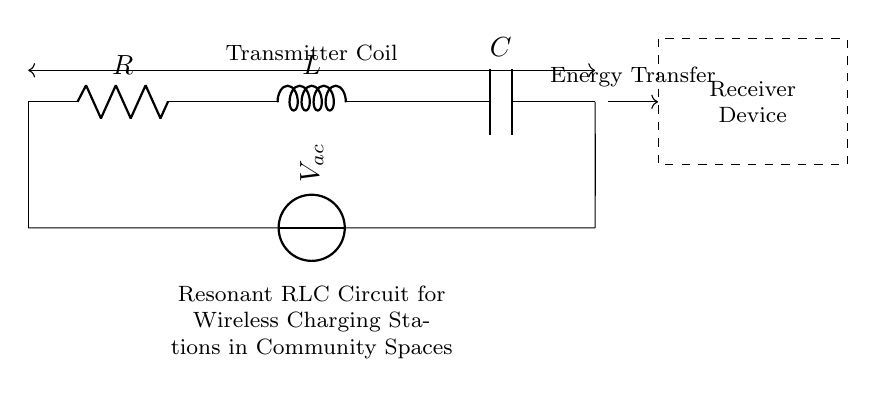What components are in the circuit? The circuit comprises a resistor, an inductor, and a capacitor. These components can be identified by their labels (R, L, C) in the diagram.
Answer: resistor, inductor, capacitor What is the voltage indicated in the circuit? The voltage source, indicated as V_ac, is connected across the components of the circuit. The specific value is not given in the diagram, but its presence signifies an alternating current.
Answer: V_ac How are the components connected in the circuit? The components are connected in series, as indicated by the straight lines connecting them one after the other. This shows a sequential connection from the resistor to the inductor and then to the capacitor.
Answer: in series What type of circuit is this? This is a resonant RLC circuit, which is designed specifically for wireless energy transfer, signified by the context provided and the arrangement of R, L, and C in the circuit.
Answer: resonant RLC circuit What is the primary function of this circuit? The primary function is energy transfer, as indicated by the label “Energy Transfer” connecting the transmitter coil to the receiver device in the circuit diagram.
Answer: energy transfer What happens when the circuit resonates? When the circuit resonates at its natural frequency, the impedance of the circuit decreases, allowing maximum current to flow, which enhances the efficiency of wireless charging.
Answer: maximum current flow What does the dashed rectangle represent in this circuit? The dashed rectangle represents the receiver device that interacts with the resonant RLC circuit to receive the energy transferred wirelessly from the transmitter coil.
Answer: receiver device 